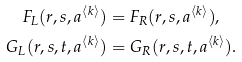Convert formula to latex. <formula><loc_0><loc_0><loc_500><loc_500>F _ { L } ( r , s , a ^ { \langle k \rangle } ) & = F _ { R } ( r , s , a ^ { \langle k \rangle } ) , \\ G _ { L } ( r , s , t , a ^ { \langle k \rangle } ) & = G _ { R } ( r , s , t , a ^ { \langle k \rangle } ) .</formula> 